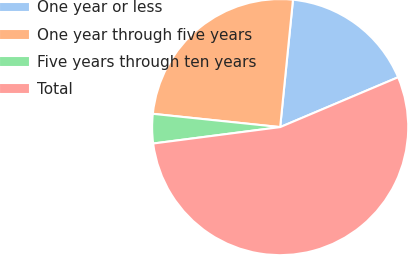Convert chart to OTSL. <chart><loc_0><loc_0><loc_500><loc_500><pie_chart><fcel>One year or less<fcel>One year through five years<fcel>Five years through ten years<fcel>Total<nl><fcel>17.04%<fcel>24.94%<fcel>3.7%<fcel>54.32%<nl></chart> 